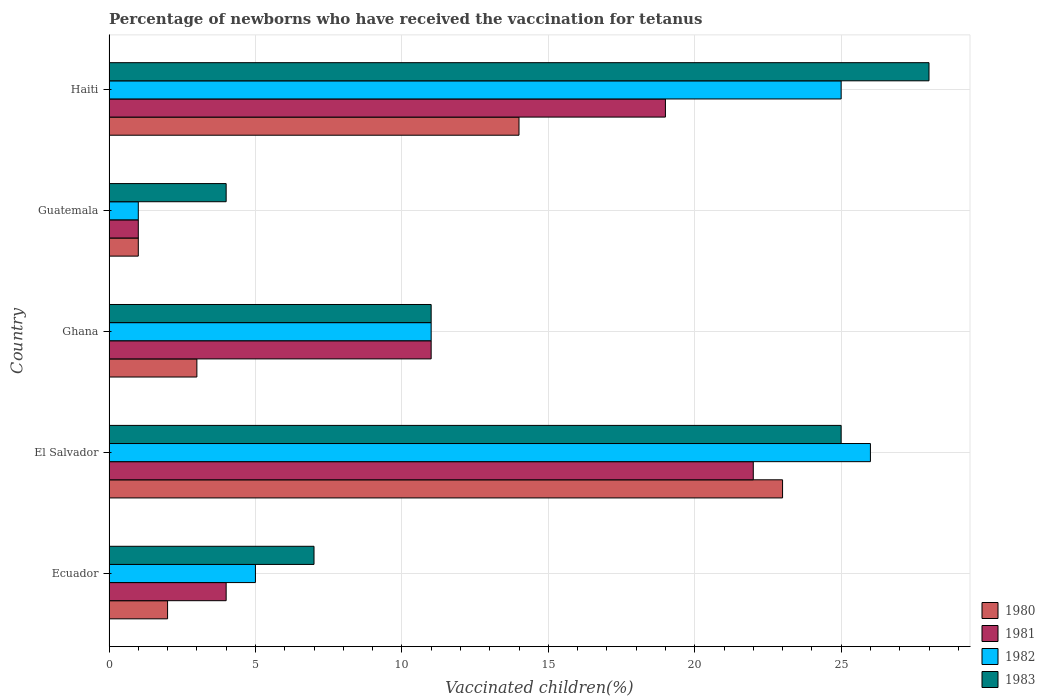Are the number of bars on each tick of the Y-axis equal?
Make the answer very short. Yes. How many bars are there on the 3rd tick from the top?
Your answer should be compact. 4. What is the label of the 3rd group of bars from the top?
Offer a terse response. Ghana. What is the percentage of vaccinated children in 1982 in Ghana?
Keep it short and to the point. 11. Across all countries, what is the minimum percentage of vaccinated children in 1982?
Your answer should be very brief. 1. In which country was the percentage of vaccinated children in 1983 maximum?
Provide a succinct answer. Haiti. In which country was the percentage of vaccinated children in 1983 minimum?
Your answer should be compact. Guatemala. What is the average percentage of vaccinated children in 1982 per country?
Ensure brevity in your answer.  13.6. In how many countries, is the percentage of vaccinated children in 1983 greater than 15 %?
Provide a short and direct response. 2. In how many countries, is the percentage of vaccinated children in 1981 greater than the average percentage of vaccinated children in 1981 taken over all countries?
Provide a short and direct response. 2. Is it the case that in every country, the sum of the percentage of vaccinated children in 1980 and percentage of vaccinated children in 1983 is greater than the sum of percentage of vaccinated children in 1981 and percentage of vaccinated children in 1982?
Your response must be concise. No. What does the 2nd bar from the top in Haiti represents?
Your answer should be very brief. 1982. What does the 1st bar from the bottom in Ecuador represents?
Offer a terse response. 1980. How many bars are there?
Make the answer very short. 20. What is the difference between two consecutive major ticks on the X-axis?
Offer a terse response. 5. Does the graph contain any zero values?
Give a very brief answer. No. Where does the legend appear in the graph?
Ensure brevity in your answer.  Bottom right. What is the title of the graph?
Provide a succinct answer. Percentage of newborns who have received the vaccination for tetanus. What is the label or title of the X-axis?
Your answer should be compact. Vaccinated children(%). What is the Vaccinated children(%) of 1981 in Ecuador?
Give a very brief answer. 4. What is the Vaccinated children(%) of 1982 in Ecuador?
Your answer should be very brief. 5. What is the Vaccinated children(%) of 1980 in El Salvador?
Your response must be concise. 23. What is the Vaccinated children(%) in 1981 in El Salvador?
Your answer should be very brief. 22. What is the Vaccinated children(%) of 1983 in El Salvador?
Provide a short and direct response. 25. What is the Vaccinated children(%) in 1981 in Ghana?
Ensure brevity in your answer.  11. What is the Vaccinated children(%) of 1980 in Guatemala?
Offer a terse response. 1. What is the Vaccinated children(%) of 1982 in Guatemala?
Your response must be concise. 1. What is the Vaccinated children(%) of 1983 in Guatemala?
Provide a short and direct response. 4. What is the Vaccinated children(%) of 1980 in Haiti?
Your response must be concise. 14. What is the Vaccinated children(%) of 1982 in Haiti?
Ensure brevity in your answer.  25. What is the Vaccinated children(%) of 1983 in Haiti?
Make the answer very short. 28. Across all countries, what is the maximum Vaccinated children(%) of 1981?
Offer a very short reply. 22. Across all countries, what is the maximum Vaccinated children(%) of 1982?
Your answer should be compact. 26. Across all countries, what is the maximum Vaccinated children(%) in 1983?
Keep it short and to the point. 28. Across all countries, what is the minimum Vaccinated children(%) of 1980?
Offer a terse response. 1. Across all countries, what is the minimum Vaccinated children(%) in 1981?
Provide a succinct answer. 1. Across all countries, what is the minimum Vaccinated children(%) of 1982?
Your response must be concise. 1. Across all countries, what is the minimum Vaccinated children(%) of 1983?
Offer a very short reply. 4. What is the total Vaccinated children(%) of 1981 in the graph?
Make the answer very short. 57. What is the total Vaccinated children(%) in 1983 in the graph?
Provide a succinct answer. 75. What is the difference between the Vaccinated children(%) in 1980 in Ecuador and that in El Salvador?
Your answer should be compact. -21. What is the difference between the Vaccinated children(%) of 1981 in Ecuador and that in El Salvador?
Offer a terse response. -18. What is the difference between the Vaccinated children(%) in 1982 in Ecuador and that in El Salvador?
Offer a terse response. -21. What is the difference between the Vaccinated children(%) of 1983 in Ecuador and that in El Salvador?
Your response must be concise. -18. What is the difference between the Vaccinated children(%) of 1981 in Ecuador and that in Ghana?
Make the answer very short. -7. What is the difference between the Vaccinated children(%) of 1982 in Ecuador and that in Ghana?
Give a very brief answer. -6. What is the difference between the Vaccinated children(%) of 1983 in Ecuador and that in Ghana?
Your answer should be very brief. -4. What is the difference between the Vaccinated children(%) in 1980 in Ecuador and that in Guatemala?
Provide a succinct answer. 1. What is the difference between the Vaccinated children(%) in 1982 in Ecuador and that in Guatemala?
Your response must be concise. 4. What is the difference between the Vaccinated children(%) in 1983 in Ecuador and that in Guatemala?
Provide a short and direct response. 3. What is the difference between the Vaccinated children(%) of 1980 in Ecuador and that in Haiti?
Offer a very short reply. -12. What is the difference between the Vaccinated children(%) of 1981 in Ecuador and that in Haiti?
Your answer should be compact. -15. What is the difference between the Vaccinated children(%) in 1983 in El Salvador and that in Ghana?
Offer a very short reply. 14. What is the difference between the Vaccinated children(%) of 1981 in El Salvador and that in Guatemala?
Provide a succinct answer. 21. What is the difference between the Vaccinated children(%) of 1982 in El Salvador and that in Guatemala?
Offer a very short reply. 25. What is the difference between the Vaccinated children(%) of 1983 in El Salvador and that in Guatemala?
Keep it short and to the point. 21. What is the difference between the Vaccinated children(%) in 1980 in El Salvador and that in Haiti?
Make the answer very short. 9. What is the difference between the Vaccinated children(%) in 1981 in El Salvador and that in Haiti?
Offer a very short reply. 3. What is the difference between the Vaccinated children(%) of 1982 in El Salvador and that in Haiti?
Your response must be concise. 1. What is the difference between the Vaccinated children(%) in 1983 in El Salvador and that in Haiti?
Your answer should be very brief. -3. What is the difference between the Vaccinated children(%) of 1980 in Ghana and that in Guatemala?
Your response must be concise. 2. What is the difference between the Vaccinated children(%) of 1981 in Ghana and that in Guatemala?
Provide a short and direct response. 10. What is the difference between the Vaccinated children(%) of 1980 in Ghana and that in Haiti?
Give a very brief answer. -11. What is the difference between the Vaccinated children(%) in 1980 in Guatemala and that in Haiti?
Your answer should be very brief. -13. What is the difference between the Vaccinated children(%) in 1981 in Guatemala and that in Haiti?
Provide a short and direct response. -18. What is the difference between the Vaccinated children(%) in 1982 in Guatemala and that in Haiti?
Offer a very short reply. -24. What is the difference between the Vaccinated children(%) in 1980 in Ecuador and the Vaccinated children(%) in 1982 in El Salvador?
Your answer should be compact. -24. What is the difference between the Vaccinated children(%) in 1980 in Ecuador and the Vaccinated children(%) in 1983 in El Salvador?
Keep it short and to the point. -23. What is the difference between the Vaccinated children(%) in 1981 in Ecuador and the Vaccinated children(%) in 1982 in El Salvador?
Make the answer very short. -22. What is the difference between the Vaccinated children(%) of 1981 in Ecuador and the Vaccinated children(%) of 1983 in El Salvador?
Give a very brief answer. -21. What is the difference between the Vaccinated children(%) in 1980 in Ecuador and the Vaccinated children(%) in 1981 in Ghana?
Keep it short and to the point. -9. What is the difference between the Vaccinated children(%) in 1980 in Ecuador and the Vaccinated children(%) in 1983 in Ghana?
Your answer should be compact. -9. What is the difference between the Vaccinated children(%) of 1981 in Ecuador and the Vaccinated children(%) of 1983 in Ghana?
Your response must be concise. -7. What is the difference between the Vaccinated children(%) of 1980 in Ecuador and the Vaccinated children(%) of 1983 in Guatemala?
Offer a terse response. -2. What is the difference between the Vaccinated children(%) in 1981 in Ecuador and the Vaccinated children(%) in 1983 in Guatemala?
Make the answer very short. 0. What is the difference between the Vaccinated children(%) in 1980 in Ecuador and the Vaccinated children(%) in 1981 in Haiti?
Provide a short and direct response. -17. What is the difference between the Vaccinated children(%) in 1980 in Ecuador and the Vaccinated children(%) in 1982 in Haiti?
Your response must be concise. -23. What is the difference between the Vaccinated children(%) in 1980 in El Salvador and the Vaccinated children(%) in 1983 in Ghana?
Ensure brevity in your answer.  12. What is the difference between the Vaccinated children(%) of 1981 in El Salvador and the Vaccinated children(%) of 1983 in Ghana?
Offer a very short reply. 11. What is the difference between the Vaccinated children(%) of 1982 in El Salvador and the Vaccinated children(%) of 1983 in Ghana?
Offer a very short reply. 15. What is the difference between the Vaccinated children(%) in 1980 in El Salvador and the Vaccinated children(%) in 1981 in Guatemala?
Provide a short and direct response. 22. What is the difference between the Vaccinated children(%) of 1980 in El Salvador and the Vaccinated children(%) of 1982 in Guatemala?
Ensure brevity in your answer.  22. What is the difference between the Vaccinated children(%) of 1980 in El Salvador and the Vaccinated children(%) of 1983 in Guatemala?
Offer a very short reply. 19. What is the difference between the Vaccinated children(%) of 1981 in El Salvador and the Vaccinated children(%) of 1983 in Guatemala?
Provide a short and direct response. 18. What is the difference between the Vaccinated children(%) of 1982 in El Salvador and the Vaccinated children(%) of 1983 in Guatemala?
Give a very brief answer. 22. What is the difference between the Vaccinated children(%) of 1981 in El Salvador and the Vaccinated children(%) of 1983 in Haiti?
Ensure brevity in your answer.  -6. What is the difference between the Vaccinated children(%) of 1980 in Ghana and the Vaccinated children(%) of 1983 in Guatemala?
Provide a succinct answer. -1. What is the difference between the Vaccinated children(%) of 1981 in Ghana and the Vaccinated children(%) of 1982 in Guatemala?
Make the answer very short. 10. What is the difference between the Vaccinated children(%) in 1981 in Ghana and the Vaccinated children(%) in 1983 in Guatemala?
Offer a terse response. 7. What is the difference between the Vaccinated children(%) of 1980 in Ghana and the Vaccinated children(%) of 1981 in Haiti?
Your answer should be very brief. -16. What is the difference between the Vaccinated children(%) of 1981 in Ghana and the Vaccinated children(%) of 1982 in Haiti?
Give a very brief answer. -14. What is the difference between the Vaccinated children(%) of 1980 in Guatemala and the Vaccinated children(%) of 1981 in Haiti?
Provide a short and direct response. -18. What is the difference between the Vaccinated children(%) in 1980 in Guatemala and the Vaccinated children(%) in 1983 in Haiti?
Make the answer very short. -27. What is the difference between the Vaccinated children(%) of 1981 in Guatemala and the Vaccinated children(%) of 1982 in Haiti?
Keep it short and to the point. -24. What is the average Vaccinated children(%) of 1980 per country?
Your answer should be very brief. 8.6. What is the average Vaccinated children(%) in 1982 per country?
Provide a succinct answer. 13.6. What is the difference between the Vaccinated children(%) in 1982 and Vaccinated children(%) in 1983 in Ecuador?
Ensure brevity in your answer.  -2. What is the difference between the Vaccinated children(%) of 1981 and Vaccinated children(%) of 1982 in El Salvador?
Keep it short and to the point. -4. What is the difference between the Vaccinated children(%) of 1982 and Vaccinated children(%) of 1983 in El Salvador?
Your answer should be compact. 1. What is the difference between the Vaccinated children(%) in 1980 and Vaccinated children(%) in 1982 in Ghana?
Your answer should be compact. -8. What is the difference between the Vaccinated children(%) in 1981 and Vaccinated children(%) in 1982 in Ghana?
Make the answer very short. 0. What is the difference between the Vaccinated children(%) in 1981 and Vaccinated children(%) in 1983 in Ghana?
Provide a short and direct response. 0. What is the difference between the Vaccinated children(%) of 1980 and Vaccinated children(%) of 1982 in Guatemala?
Provide a succinct answer. 0. What is the difference between the Vaccinated children(%) of 1980 and Vaccinated children(%) of 1983 in Guatemala?
Offer a very short reply. -3. What is the difference between the Vaccinated children(%) of 1982 and Vaccinated children(%) of 1983 in Guatemala?
Your answer should be very brief. -3. What is the difference between the Vaccinated children(%) of 1980 and Vaccinated children(%) of 1982 in Haiti?
Offer a very short reply. -11. What is the difference between the Vaccinated children(%) of 1980 and Vaccinated children(%) of 1983 in Haiti?
Make the answer very short. -14. What is the difference between the Vaccinated children(%) of 1982 and Vaccinated children(%) of 1983 in Haiti?
Offer a terse response. -3. What is the ratio of the Vaccinated children(%) in 1980 in Ecuador to that in El Salvador?
Your response must be concise. 0.09. What is the ratio of the Vaccinated children(%) of 1981 in Ecuador to that in El Salvador?
Provide a short and direct response. 0.18. What is the ratio of the Vaccinated children(%) in 1982 in Ecuador to that in El Salvador?
Your answer should be compact. 0.19. What is the ratio of the Vaccinated children(%) in 1983 in Ecuador to that in El Salvador?
Offer a terse response. 0.28. What is the ratio of the Vaccinated children(%) of 1980 in Ecuador to that in Ghana?
Your answer should be very brief. 0.67. What is the ratio of the Vaccinated children(%) in 1981 in Ecuador to that in Ghana?
Offer a terse response. 0.36. What is the ratio of the Vaccinated children(%) in 1982 in Ecuador to that in Ghana?
Provide a succinct answer. 0.45. What is the ratio of the Vaccinated children(%) in 1983 in Ecuador to that in Ghana?
Make the answer very short. 0.64. What is the ratio of the Vaccinated children(%) in 1980 in Ecuador to that in Haiti?
Make the answer very short. 0.14. What is the ratio of the Vaccinated children(%) in 1981 in Ecuador to that in Haiti?
Provide a short and direct response. 0.21. What is the ratio of the Vaccinated children(%) in 1983 in Ecuador to that in Haiti?
Offer a very short reply. 0.25. What is the ratio of the Vaccinated children(%) in 1980 in El Salvador to that in Ghana?
Offer a very short reply. 7.67. What is the ratio of the Vaccinated children(%) of 1981 in El Salvador to that in Ghana?
Your answer should be compact. 2. What is the ratio of the Vaccinated children(%) in 1982 in El Salvador to that in Ghana?
Provide a short and direct response. 2.36. What is the ratio of the Vaccinated children(%) of 1983 in El Salvador to that in Ghana?
Give a very brief answer. 2.27. What is the ratio of the Vaccinated children(%) of 1981 in El Salvador to that in Guatemala?
Offer a terse response. 22. What is the ratio of the Vaccinated children(%) in 1983 in El Salvador to that in Guatemala?
Keep it short and to the point. 6.25. What is the ratio of the Vaccinated children(%) of 1980 in El Salvador to that in Haiti?
Keep it short and to the point. 1.64. What is the ratio of the Vaccinated children(%) of 1981 in El Salvador to that in Haiti?
Offer a very short reply. 1.16. What is the ratio of the Vaccinated children(%) of 1982 in El Salvador to that in Haiti?
Your answer should be compact. 1.04. What is the ratio of the Vaccinated children(%) in 1983 in El Salvador to that in Haiti?
Ensure brevity in your answer.  0.89. What is the ratio of the Vaccinated children(%) of 1980 in Ghana to that in Guatemala?
Your response must be concise. 3. What is the ratio of the Vaccinated children(%) in 1983 in Ghana to that in Guatemala?
Provide a short and direct response. 2.75. What is the ratio of the Vaccinated children(%) in 1980 in Ghana to that in Haiti?
Offer a very short reply. 0.21. What is the ratio of the Vaccinated children(%) in 1981 in Ghana to that in Haiti?
Your answer should be compact. 0.58. What is the ratio of the Vaccinated children(%) in 1982 in Ghana to that in Haiti?
Your answer should be very brief. 0.44. What is the ratio of the Vaccinated children(%) of 1983 in Ghana to that in Haiti?
Provide a short and direct response. 0.39. What is the ratio of the Vaccinated children(%) in 1980 in Guatemala to that in Haiti?
Your answer should be very brief. 0.07. What is the ratio of the Vaccinated children(%) of 1981 in Guatemala to that in Haiti?
Provide a succinct answer. 0.05. What is the ratio of the Vaccinated children(%) of 1983 in Guatemala to that in Haiti?
Your answer should be compact. 0.14. What is the difference between the highest and the second highest Vaccinated children(%) in 1980?
Offer a terse response. 9. What is the difference between the highest and the second highest Vaccinated children(%) in 1981?
Provide a short and direct response. 3. What is the difference between the highest and the second highest Vaccinated children(%) in 1983?
Your answer should be very brief. 3. What is the difference between the highest and the lowest Vaccinated children(%) of 1980?
Keep it short and to the point. 22. What is the difference between the highest and the lowest Vaccinated children(%) of 1982?
Ensure brevity in your answer.  25. 